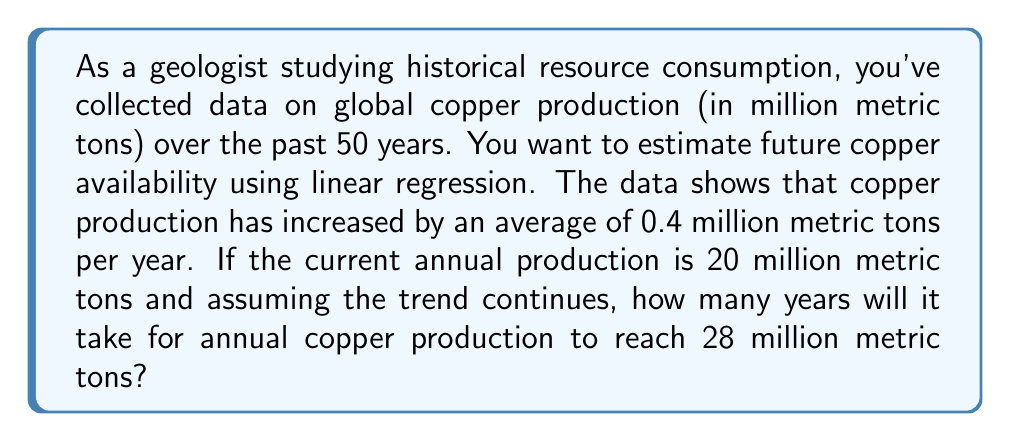Teach me how to tackle this problem. To solve this problem, we'll use linear regression analysis and the given information to create an equation and solve for the time required.

1. Let's define our variables:
   $y$ = annual copper production in million metric tons
   $x$ = number of years from the present
   $m$ = slope (rate of increase per year) = 0.4 million metric tons/year
   $b$ = y-intercept (current production) = 20 million metric tons

2. The linear equation for this trend is:
   $y = mx + b$

3. Substituting our known values:
   $y = 0.4x + 20$

4. We want to find when $y = 28$ million metric tons:
   $28 = 0.4x + 20$

5. Solve for $x$:
   $28 - 20 = 0.4x$
   $8 = 0.4x$
   $x = 8 \div 0.4 = 20$

Therefore, it will take 20 years for annual copper production to reach 28 million metric tons if the current trend continues.

This analysis assumes a constant linear growth, which may not always be accurate for long-term resource projections. In reality, factors such as new technologies, economic changes, or resource depletion could alter this trend.
Answer: 20 years 